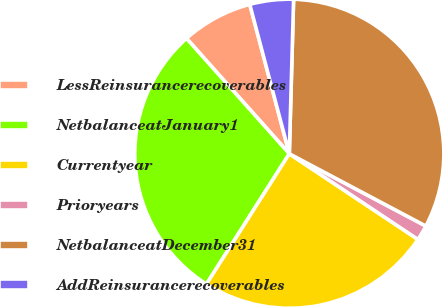<chart> <loc_0><loc_0><loc_500><loc_500><pie_chart><fcel>LessReinsurancerecoverables<fcel>NetbalanceatJanuary1<fcel>Currentyear<fcel>Prioryears<fcel>NetbalanceatDecember31<fcel>AddReinsurancerecoverables<nl><fcel>7.47%<fcel>29.4%<fcel>24.66%<fcel>1.6%<fcel>32.31%<fcel>4.56%<nl></chart> 